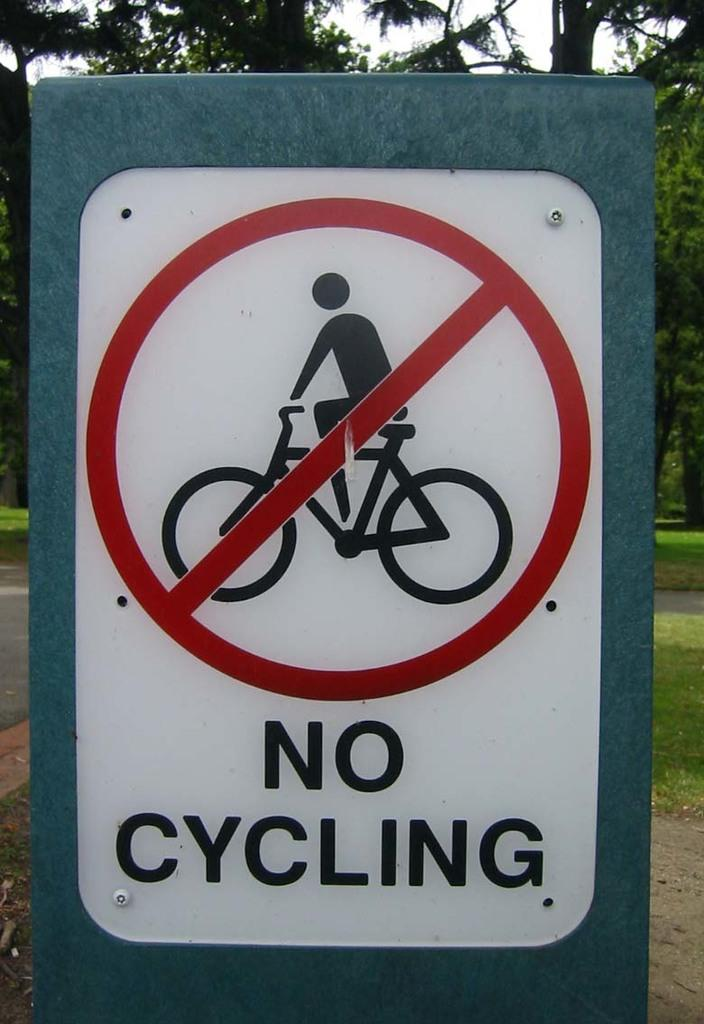What is the main object in the image? There is an instruction board in the image. What information is provided on the instruction board? The instruction board contains text and has a symbol. What type of natural environment is visible in the image? There is grass, trees, and the sky visible in the image. What type of branch is the person holding during their voyage in the image? There is no person or voyage present in the image; it features an instruction board with text and a symbol, along with a natural environment. 